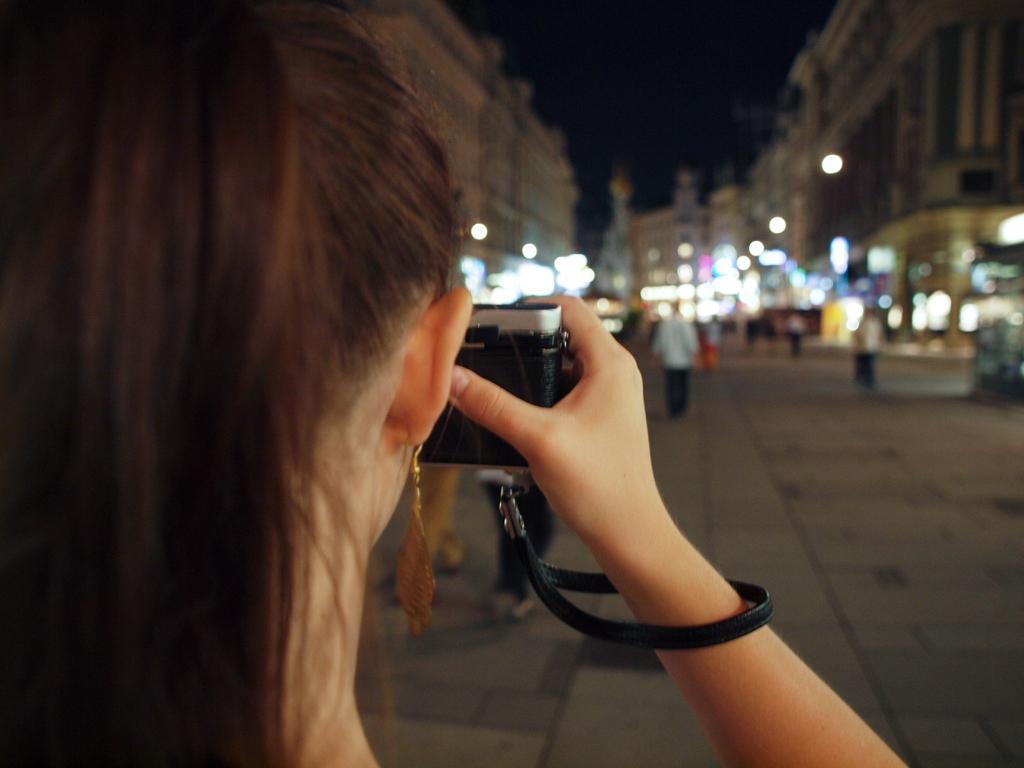How would you summarize this image in a sentence or two? Here we can see a woman with a camera in her hand and in front of her man walking on the road and buildings present 